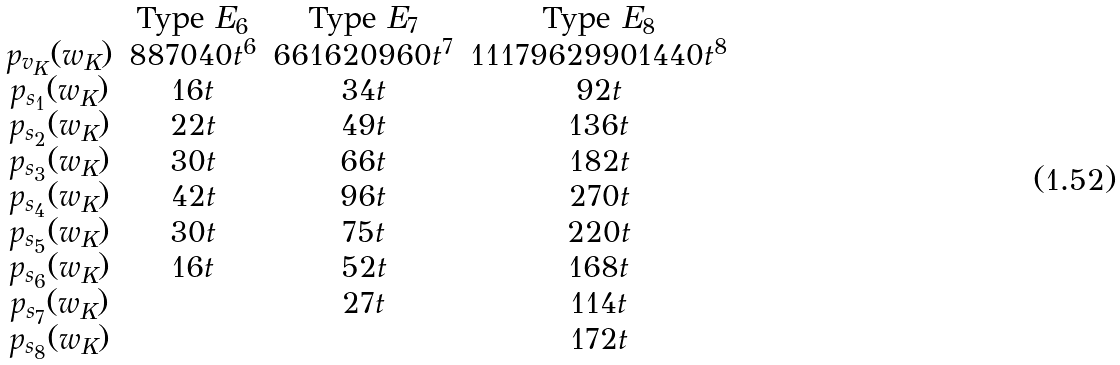Convert formula to latex. <formula><loc_0><loc_0><loc_500><loc_500>\begin{matrix} & \text {Type } E _ { 6 } & \text {Type } E _ { 7 } & \text {Type } E _ { 8 } \\ p _ { v _ { K } } ( w _ { K } ) & 8 8 7 0 4 0 t ^ { 6 } & 6 6 1 6 2 0 9 6 0 t ^ { 7 } & 1 1 1 7 9 6 2 9 9 0 1 4 4 0 t ^ { 8 } \\ p _ { s _ { 1 } } ( w _ { K } ) & 1 6 t & 3 4 t & 9 2 t \\ p _ { s _ { 2 } } ( w _ { K } ) & 2 2 t & 4 9 t & 1 3 6 t \\ p _ { s _ { 3 } } ( w _ { K } ) & 3 0 t & 6 6 t & 1 8 2 t \\ p _ { s _ { 4 } } ( w _ { K } ) & 4 2 t & 9 6 t & 2 7 0 t \\ p _ { s _ { 5 } } ( w _ { K } ) & 3 0 t & 7 5 t & 2 2 0 t \\ p _ { s _ { 6 } } ( w _ { K } ) & 1 6 t & 5 2 t & 1 6 8 t \\ p _ { s _ { 7 } } ( w _ { K } ) & & 2 7 t & 1 1 4 t \\ p _ { s _ { 8 } } ( w _ { K } ) & & & 1 7 2 t \end{matrix}</formula> 